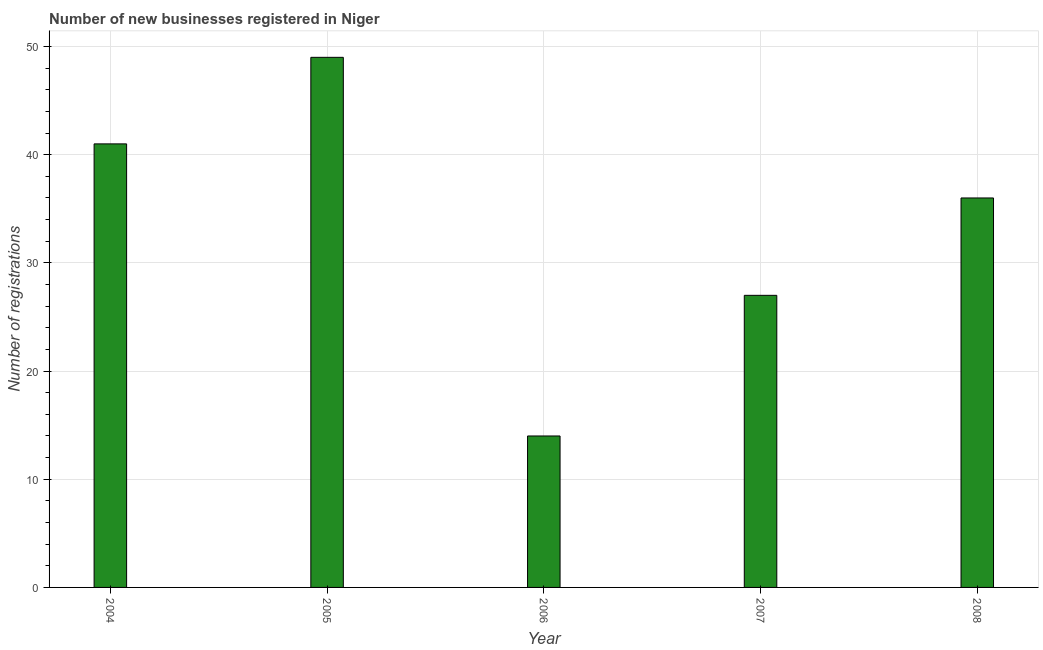Does the graph contain any zero values?
Your answer should be very brief. No. What is the title of the graph?
Offer a very short reply. Number of new businesses registered in Niger. What is the label or title of the Y-axis?
Offer a terse response. Number of registrations. Across all years, what is the maximum number of new business registrations?
Give a very brief answer. 49. Across all years, what is the minimum number of new business registrations?
Your answer should be compact. 14. What is the sum of the number of new business registrations?
Keep it short and to the point. 167. What is the median number of new business registrations?
Provide a short and direct response. 36. In how many years, is the number of new business registrations greater than 24 ?
Offer a terse response. 4. What is the ratio of the number of new business registrations in 2007 to that in 2008?
Provide a short and direct response. 0.75. Is the number of new business registrations in 2004 less than that in 2005?
Offer a terse response. Yes. What is the difference between the highest and the second highest number of new business registrations?
Your answer should be very brief. 8. Is the sum of the number of new business registrations in 2006 and 2008 greater than the maximum number of new business registrations across all years?
Provide a succinct answer. Yes. What is the difference between the highest and the lowest number of new business registrations?
Offer a terse response. 35. How many bars are there?
Offer a very short reply. 5. Are the values on the major ticks of Y-axis written in scientific E-notation?
Provide a succinct answer. No. What is the Number of registrations of 2004?
Provide a short and direct response. 41. What is the difference between the Number of registrations in 2004 and 2008?
Keep it short and to the point. 5. What is the difference between the Number of registrations in 2005 and 2006?
Provide a short and direct response. 35. What is the difference between the Number of registrations in 2005 and 2007?
Provide a succinct answer. 22. What is the difference between the Number of registrations in 2005 and 2008?
Your response must be concise. 13. What is the difference between the Number of registrations in 2006 and 2008?
Offer a very short reply. -22. What is the ratio of the Number of registrations in 2004 to that in 2005?
Your answer should be very brief. 0.84. What is the ratio of the Number of registrations in 2004 to that in 2006?
Your answer should be compact. 2.93. What is the ratio of the Number of registrations in 2004 to that in 2007?
Make the answer very short. 1.52. What is the ratio of the Number of registrations in 2004 to that in 2008?
Your response must be concise. 1.14. What is the ratio of the Number of registrations in 2005 to that in 2007?
Your answer should be compact. 1.81. What is the ratio of the Number of registrations in 2005 to that in 2008?
Ensure brevity in your answer.  1.36. What is the ratio of the Number of registrations in 2006 to that in 2007?
Offer a terse response. 0.52. What is the ratio of the Number of registrations in 2006 to that in 2008?
Provide a short and direct response. 0.39. What is the ratio of the Number of registrations in 2007 to that in 2008?
Provide a succinct answer. 0.75. 